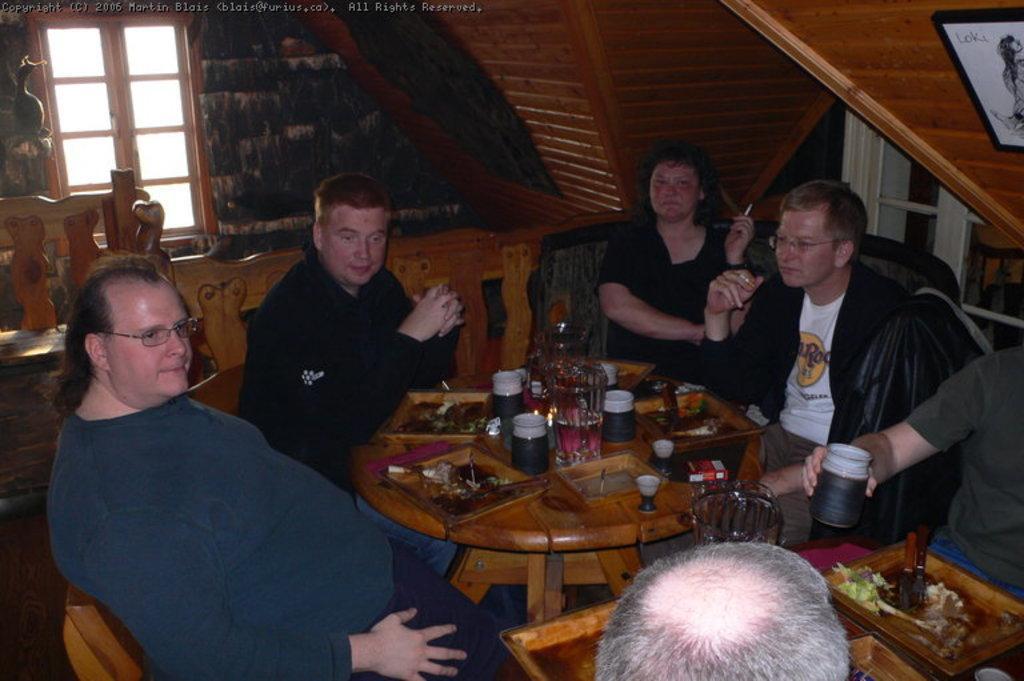Please provide a concise description of this image. In this image there are many people sitting on chairs. In the middle there is a table on it there are food,jugs,candle. In the background there is window and wall. In the right there is a photo frame. 